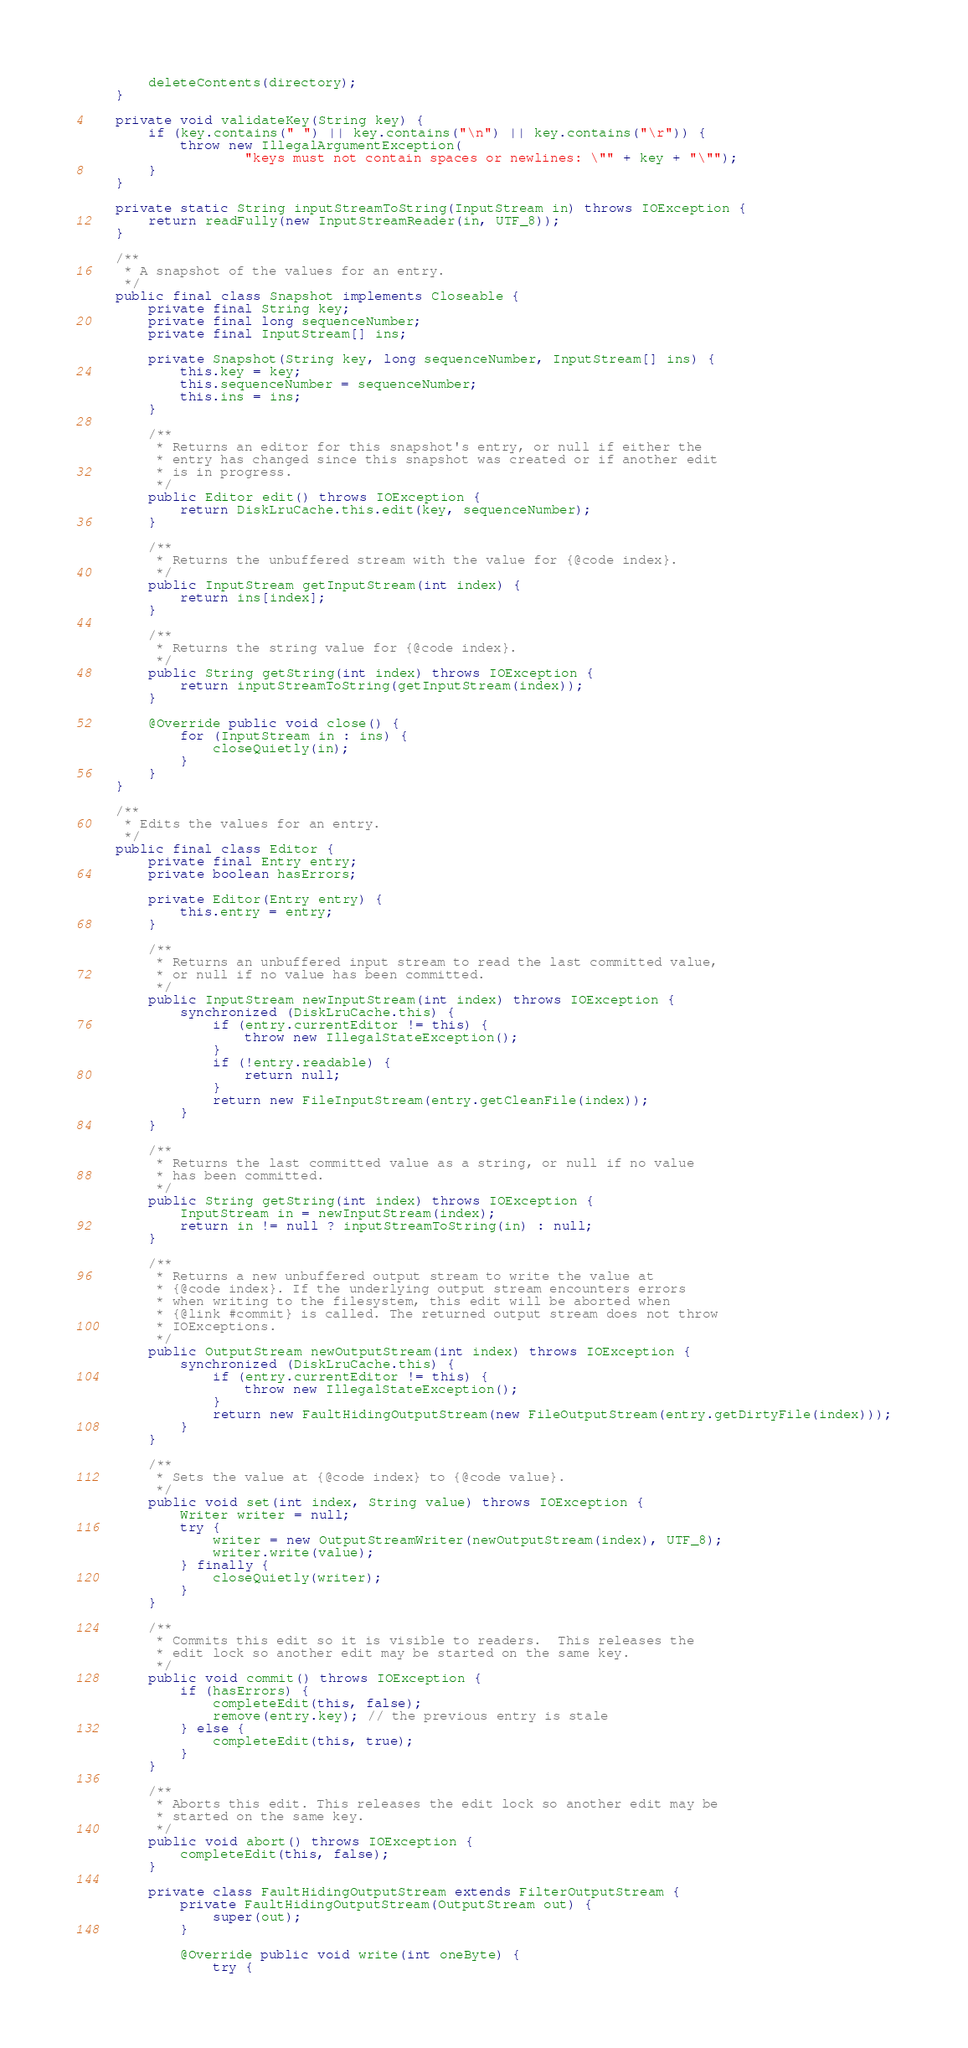<code> <loc_0><loc_0><loc_500><loc_500><_Java_>        deleteContents(directory);
    }

    private void validateKey(String key) {
        if (key.contains(" ") || key.contains("\n") || key.contains("\r")) {
            throw new IllegalArgumentException(
                    "keys must not contain spaces or newlines: \"" + key + "\"");
        }
    }

    private static String inputStreamToString(InputStream in) throws IOException {
        return readFully(new InputStreamReader(in, UTF_8));
    }

    /**
     * A snapshot of the values for an entry.
     */
    public final class Snapshot implements Closeable {
        private final String key;
        private final long sequenceNumber;
        private final InputStream[] ins;

        private Snapshot(String key, long sequenceNumber, InputStream[] ins) {
            this.key = key;
            this.sequenceNumber = sequenceNumber;
            this.ins = ins;
        }

        /**
         * Returns an editor for this snapshot's entry, or null if either the
         * entry has changed since this snapshot was created or if another edit
         * is in progress.
         */
        public Editor edit() throws IOException {
            return DiskLruCache.this.edit(key, sequenceNumber);
        }

        /**
         * Returns the unbuffered stream with the value for {@code index}.
         */
        public InputStream getInputStream(int index) {
            return ins[index];
        }

        /**
         * Returns the string value for {@code index}.
         */
        public String getString(int index) throws IOException {
            return inputStreamToString(getInputStream(index));
        }

        @Override public void close() {
            for (InputStream in : ins) {
                closeQuietly(in);
            }
        }
    }

    /**
     * Edits the values for an entry.
     */
    public final class Editor {
        private final Entry entry;
        private boolean hasErrors;

        private Editor(Entry entry) {
            this.entry = entry;
        }

        /**
         * Returns an unbuffered input stream to read the last committed value,
         * or null if no value has been committed.
         */
        public InputStream newInputStream(int index) throws IOException {
            synchronized (DiskLruCache.this) {
                if (entry.currentEditor != this) {
                    throw new IllegalStateException();
                }
                if (!entry.readable) {
                    return null;
                }
                return new FileInputStream(entry.getCleanFile(index));
            }
        }

        /**
         * Returns the last committed value as a string, or null if no value
         * has been committed.
         */
        public String getString(int index) throws IOException {
            InputStream in = newInputStream(index);
            return in != null ? inputStreamToString(in) : null;
        }

        /**
         * Returns a new unbuffered output stream to write the value at
         * {@code index}. If the underlying output stream encounters errors
         * when writing to the filesystem, this edit will be aborted when
         * {@link #commit} is called. The returned output stream does not throw
         * IOExceptions.
         */
        public OutputStream newOutputStream(int index) throws IOException {
            synchronized (DiskLruCache.this) {
                if (entry.currentEditor != this) {
                    throw new IllegalStateException();
                }
                return new FaultHidingOutputStream(new FileOutputStream(entry.getDirtyFile(index)));
            }
        }

        /**
         * Sets the value at {@code index} to {@code value}.
         */
        public void set(int index, String value) throws IOException {
            Writer writer = null;
            try {
                writer = new OutputStreamWriter(newOutputStream(index), UTF_8);
                writer.write(value);
            } finally {
                closeQuietly(writer);
            }
        }

        /**
         * Commits this edit so it is visible to readers.  This releases the
         * edit lock so another edit may be started on the same key.
         */
        public void commit() throws IOException {
            if (hasErrors) {
                completeEdit(this, false);
                remove(entry.key); // the previous entry is stale
            } else {
                completeEdit(this, true);
            }
        }

        /**
         * Aborts this edit. This releases the edit lock so another edit may be
         * started on the same key.
         */
        public void abort() throws IOException {
            completeEdit(this, false);
        }

        private class FaultHidingOutputStream extends FilterOutputStream {
            private FaultHidingOutputStream(OutputStream out) {
                super(out);
            }

            @Override public void write(int oneByte) {
                try {</code> 